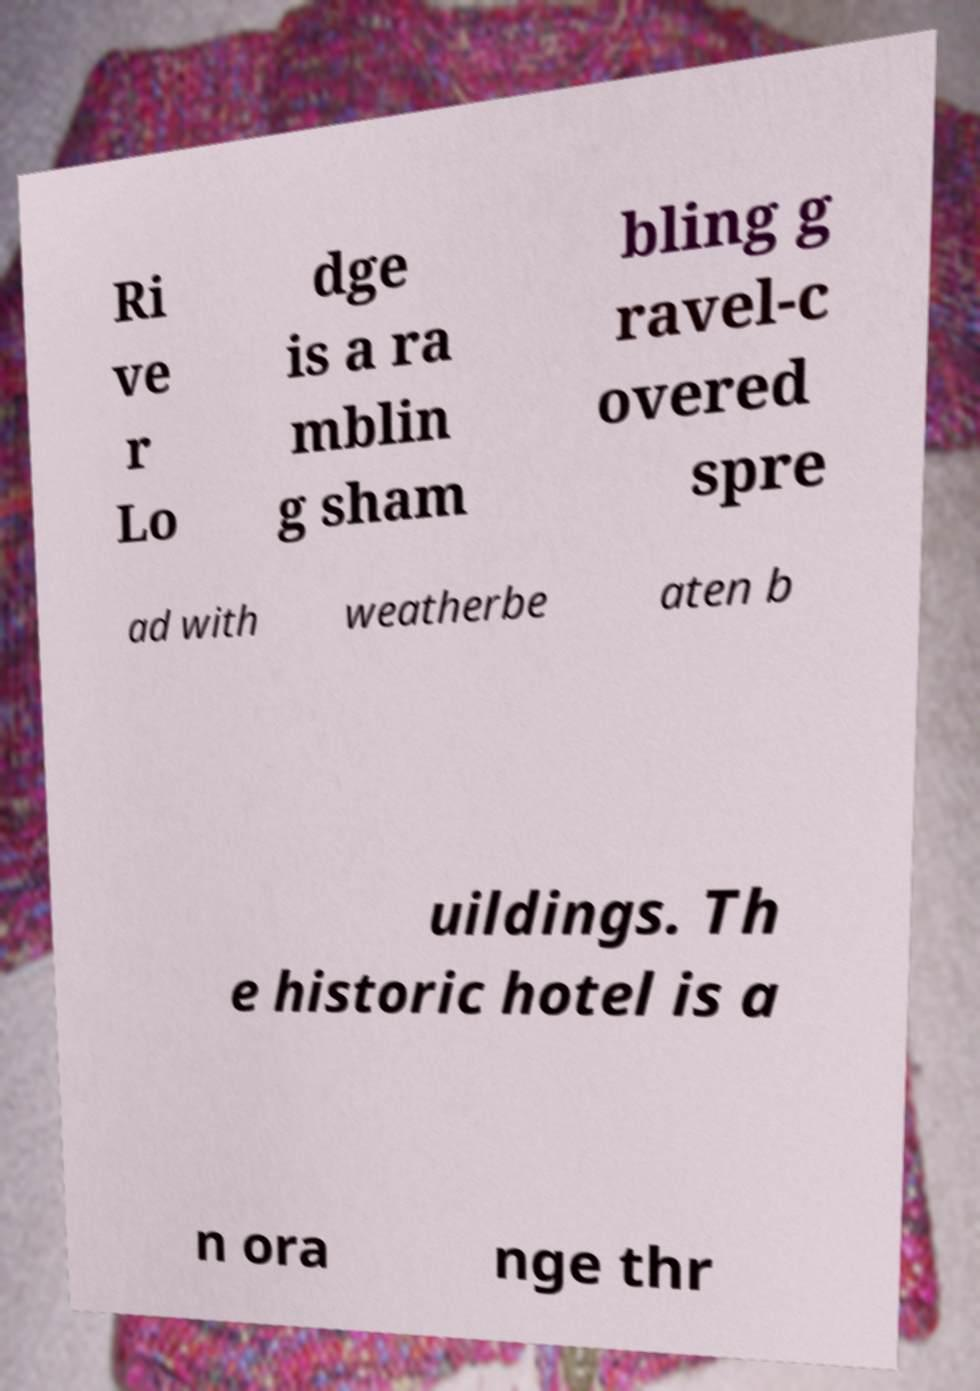Can you read and provide the text displayed in the image?This photo seems to have some interesting text. Can you extract and type it out for me? Ri ve r Lo dge is a ra mblin g sham bling g ravel-c overed spre ad with weatherbe aten b uildings. Th e historic hotel is a n ora nge thr 